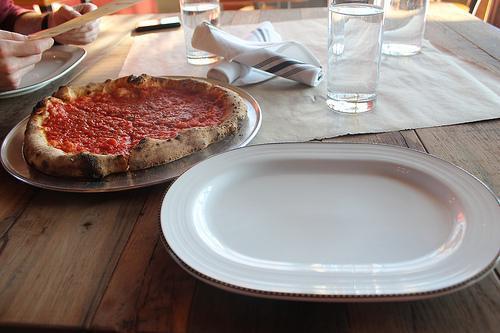How many pizza's are visible?
Give a very brief answer. 1. How many plates are there?
Give a very brief answer. 2. 